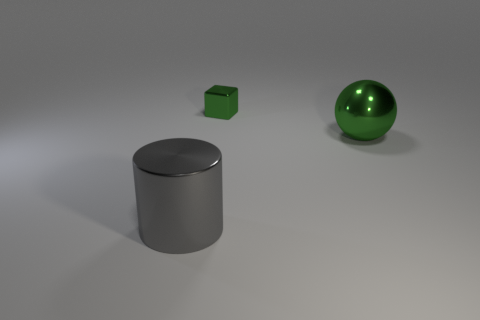Are the green ball and the green object behind the big green shiny sphere made of the same material?
Make the answer very short. Yes. How many objects are red matte things or metal cylinders?
Your answer should be very brief. 1. There is a green metal object that is in front of the tiny green shiny block; is it the same size as the object in front of the big green object?
Offer a very short reply. Yes. What number of cylinders are either green things or small red shiny objects?
Offer a terse response. 0. Are any rubber cylinders visible?
Ensure brevity in your answer.  No. Are there any other things that have the same shape as the gray metal thing?
Ensure brevity in your answer.  No. Do the large ball and the cylinder have the same color?
Your response must be concise. No. What number of objects are large metal objects in front of the large green thing or large gray matte things?
Make the answer very short. 1. There is a metallic thing that is in front of the green thing in front of the small green metal block; how many metallic objects are behind it?
Your response must be concise. 2. Are there any other things that are the same size as the metal cylinder?
Give a very brief answer. Yes. 